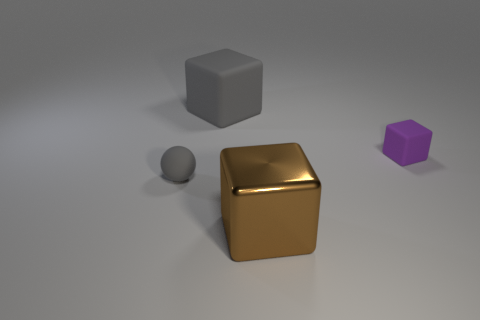What is the material of the cube that is left of the small matte cube and on the right side of the large gray rubber object?
Give a very brief answer. Metal. How many other things are the same shape as the tiny purple object?
Offer a terse response. 2. Does the tiny rubber sphere have the same color as the large rubber cube?
Provide a succinct answer. Yes. Is there anything else that has the same shape as the tiny gray matte thing?
Provide a succinct answer. No. Are there any objects of the same color as the big matte cube?
Keep it short and to the point. Yes. Do the big object that is behind the tiny purple rubber cube and the tiny thing that is on the left side of the big metallic block have the same material?
Provide a short and direct response. Yes. The small cube is what color?
Give a very brief answer. Purple. There is a brown object that is in front of the gray thing that is left of the large object that is behind the tiny gray matte sphere; what size is it?
Ensure brevity in your answer.  Large. What number of other things are the same size as the gray matte ball?
Provide a short and direct response. 1. How many purple blocks are the same material as the brown thing?
Provide a succinct answer. 0. 